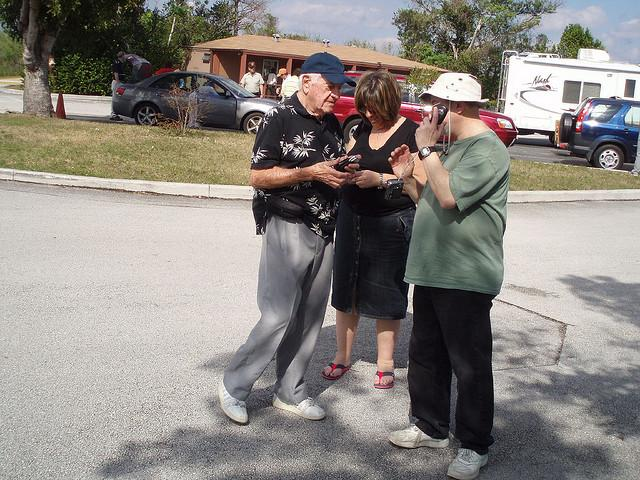Which person is the oldest? Please explain your reasoning. left man. This person has white hair and looks older. 